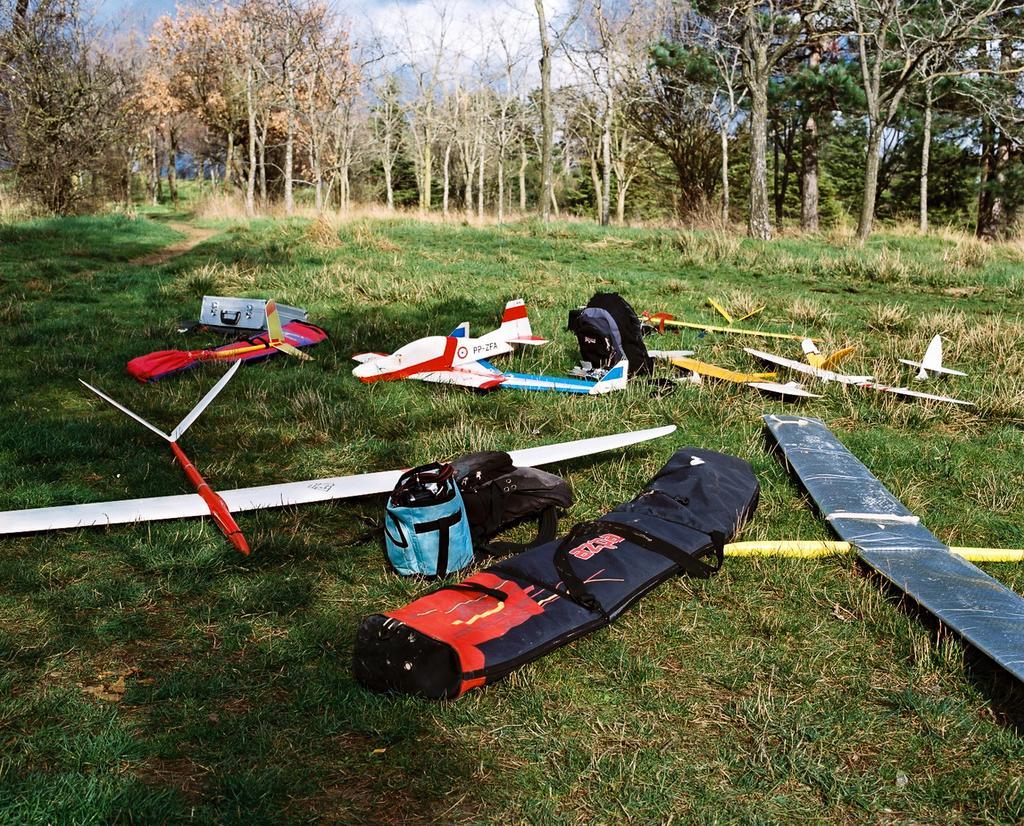Please provide a concise description of this image. In this image I can see few toy aircraft's and bags in multi color, background I can see few trees in green color and the sky is in white and blue color. 